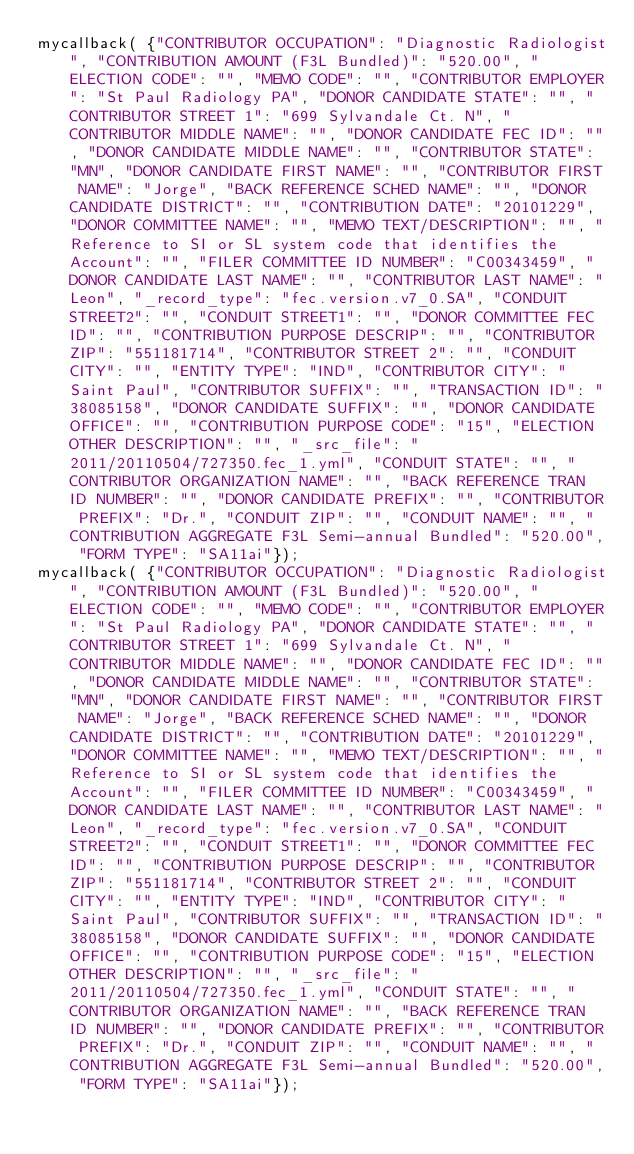Convert code to text. <code><loc_0><loc_0><loc_500><loc_500><_JavaScript_>mycallback( {"CONTRIBUTOR OCCUPATION": "Diagnostic Radiologist", "CONTRIBUTION AMOUNT (F3L Bundled)": "520.00", "ELECTION CODE": "", "MEMO CODE": "", "CONTRIBUTOR EMPLOYER": "St Paul Radiology PA", "DONOR CANDIDATE STATE": "", "CONTRIBUTOR STREET 1": "699 Sylvandale Ct. N", "CONTRIBUTOR MIDDLE NAME": "", "DONOR CANDIDATE FEC ID": "", "DONOR CANDIDATE MIDDLE NAME": "", "CONTRIBUTOR STATE": "MN", "DONOR CANDIDATE FIRST NAME": "", "CONTRIBUTOR FIRST NAME": "Jorge", "BACK REFERENCE SCHED NAME": "", "DONOR CANDIDATE DISTRICT": "", "CONTRIBUTION DATE": "20101229", "DONOR COMMITTEE NAME": "", "MEMO TEXT/DESCRIPTION": "", "Reference to SI or SL system code that identifies the Account": "", "FILER COMMITTEE ID NUMBER": "C00343459", "DONOR CANDIDATE LAST NAME": "", "CONTRIBUTOR LAST NAME": "Leon", "_record_type": "fec.version.v7_0.SA", "CONDUIT STREET2": "", "CONDUIT STREET1": "", "DONOR COMMITTEE FEC ID": "", "CONTRIBUTION PURPOSE DESCRIP": "", "CONTRIBUTOR ZIP": "551181714", "CONTRIBUTOR STREET 2": "", "CONDUIT CITY": "", "ENTITY TYPE": "IND", "CONTRIBUTOR CITY": "Saint Paul", "CONTRIBUTOR SUFFIX": "", "TRANSACTION ID": "38085158", "DONOR CANDIDATE SUFFIX": "", "DONOR CANDIDATE OFFICE": "", "CONTRIBUTION PURPOSE CODE": "15", "ELECTION OTHER DESCRIPTION": "", "_src_file": "2011/20110504/727350.fec_1.yml", "CONDUIT STATE": "", "CONTRIBUTOR ORGANIZATION NAME": "", "BACK REFERENCE TRAN ID NUMBER": "", "DONOR CANDIDATE PREFIX": "", "CONTRIBUTOR PREFIX": "Dr.", "CONDUIT ZIP": "", "CONDUIT NAME": "", "CONTRIBUTION AGGREGATE F3L Semi-annual Bundled": "520.00", "FORM TYPE": "SA11ai"});
mycallback( {"CONTRIBUTOR OCCUPATION": "Diagnostic Radiologist", "CONTRIBUTION AMOUNT (F3L Bundled)": "520.00", "ELECTION CODE": "", "MEMO CODE": "", "CONTRIBUTOR EMPLOYER": "St Paul Radiology PA", "DONOR CANDIDATE STATE": "", "CONTRIBUTOR STREET 1": "699 Sylvandale Ct. N", "CONTRIBUTOR MIDDLE NAME": "", "DONOR CANDIDATE FEC ID": "", "DONOR CANDIDATE MIDDLE NAME": "", "CONTRIBUTOR STATE": "MN", "DONOR CANDIDATE FIRST NAME": "", "CONTRIBUTOR FIRST NAME": "Jorge", "BACK REFERENCE SCHED NAME": "", "DONOR CANDIDATE DISTRICT": "", "CONTRIBUTION DATE": "20101229", "DONOR COMMITTEE NAME": "", "MEMO TEXT/DESCRIPTION": "", "Reference to SI or SL system code that identifies the Account": "", "FILER COMMITTEE ID NUMBER": "C00343459", "DONOR CANDIDATE LAST NAME": "", "CONTRIBUTOR LAST NAME": "Leon", "_record_type": "fec.version.v7_0.SA", "CONDUIT STREET2": "", "CONDUIT STREET1": "", "DONOR COMMITTEE FEC ID": "", "CONTRIBUTION PURPOSE DESCRIP": "", "CONTRIBUTOR ZIP": "551181714", "CONTRIBUTOR STREET 2": "", "CONDUIT CITY": "", "ENTITY TYPE": "IND", "CONTRIBUTOR CITY": "Saint Paul", "CONTRIBUTOR SUFFIX": "", "TRANSACTION ID": "38085158", "DONOR CANDIDATE SUFFIX": "", "DONOR CANDIDATE OFFICE": "", "CONTRIBUTION PURPOSE CODE": "15", "ELECTION OTHER DESCRIPTION": "", "_src_file": "2011/20110504/727350.fec_1.yml", "CONDUIT STATE": "", "CONTRIBUTOR ORGANIZATION NAME": "", "BACK REFERENCE TRAN ID NUMBER": "", "DONOR CANDIDATE PREFIX": "", "CONTRIBUTOR PREFIX": "Dr.", "CONDUIT ZIP": "", "CONDUIT NAME": "", "CONTRIBUTION AGGREGATE F3L Semi-annual Bundled": "520.00", "FORM TYPE": "SA11ai"});
</code> 